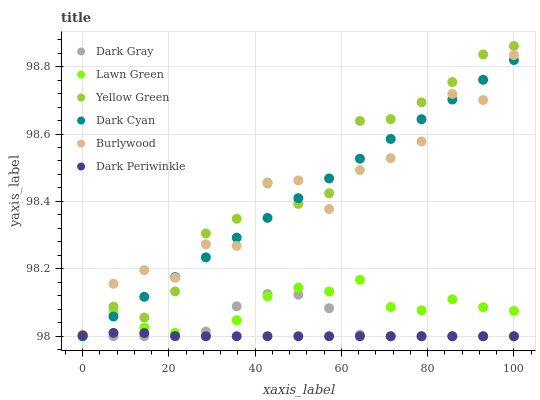Does Dark Periwinkle have the minimum area under the curve?
Answer yes or no. Yes. Does Yellow Green have the maximum area under the curve?
Answer yes or no. Yes. Does Burlywood have the minimum area under the curve?
Answer yes or no. No. Does Burlywood have the maximum area under the curve?
Answer yes or no. No. Is Dark Cyan the smoothest?
Answer yes or no. Yes. Is Burlywood the roughest?
Answer yes or no. Yes. Is Yellow Green the smoothest?
Answer yes or no. No. Is Yellow Green the roughest?
Answer yes or no. No. Does Lawn Green have the lowest value?
Answer yes or no. Yes. Does Yellow Green have the lowest value?
Answer yes or no. No. Does Yellow Green have the highest value?
Answer yes or no. Yes. Does Burlywood have the highest value?
Answer yes or no. No. Is Lawn Green less than Yellow Green?
Answer yes or no. Yes. Is Burlywood greater than Dark Periwinkle?
Answer yes or no. Yes. Does Dark Gray intersect Dark Periwinkle?
Answer yes or no. Yes. Is Dark Gray less than Dark Periwinkle?
Answer yes or no. No. Is Dark Gray greater than Dark Periwinkle?
Answer yes or no. No. Does Lawn Green intersect Yellow Green?
Answer yes or no. No. 